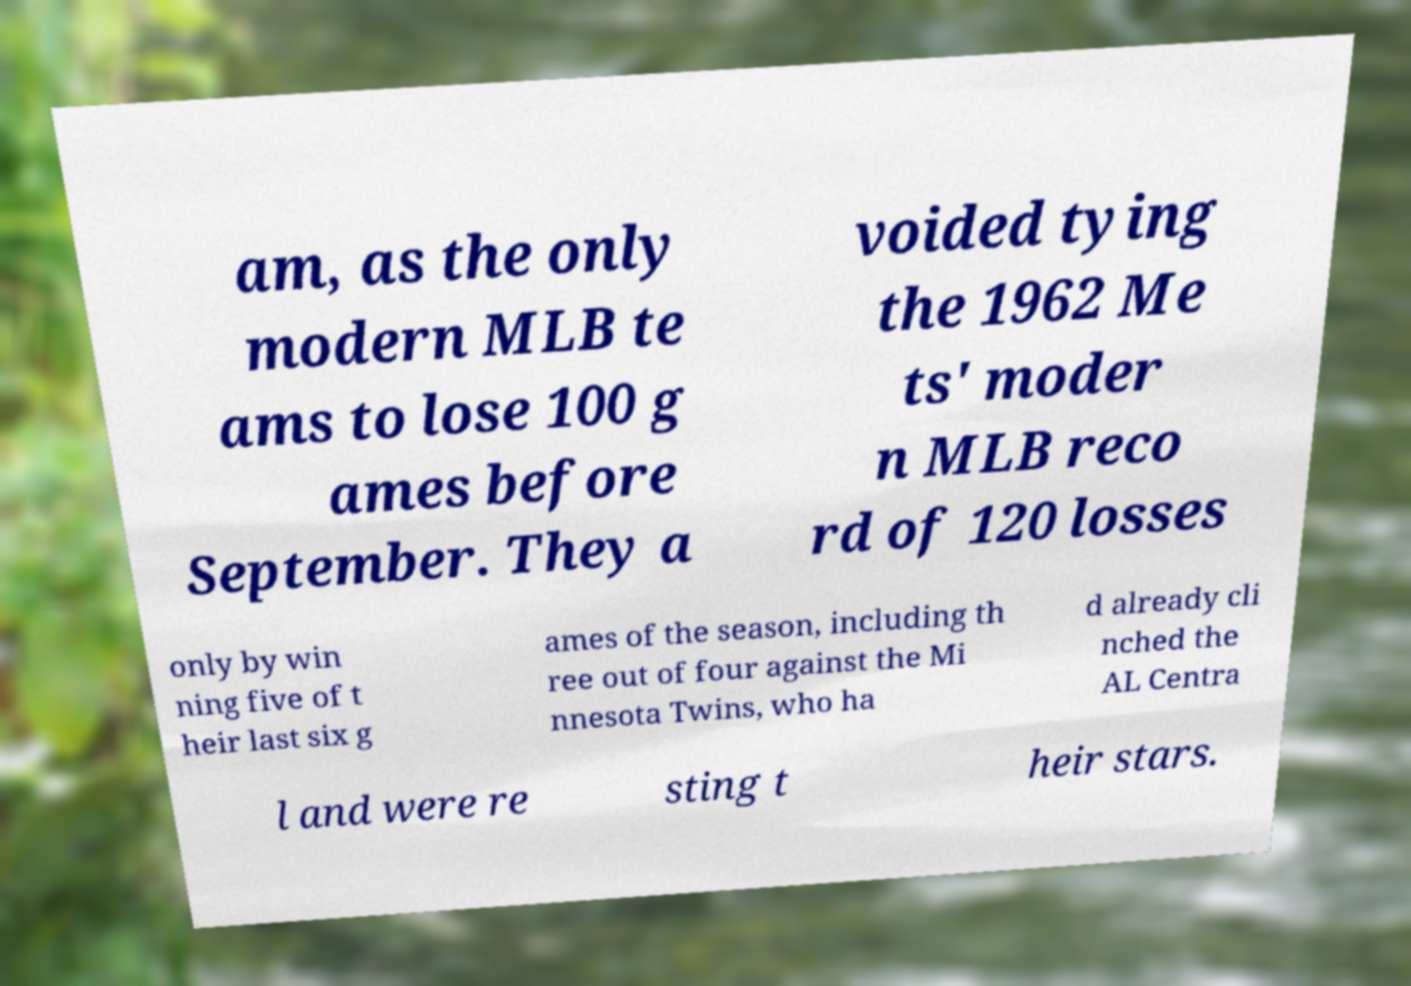Can you read and provide the text displayed in the image?This photo seems to have some interesting text. Can you extract and type it out for me? am, as the only modern MLB te ams to lose 100 g ames before September. They a voided tying the 1962 Me ts' moder n MLB reco rd of 120 losses only by win ning five of t heir last six g ames of the season, including th ree out of four against the Mi nnesota Twins, who ha d already cli nched the AL Centra l and were re sting t heir stars. 